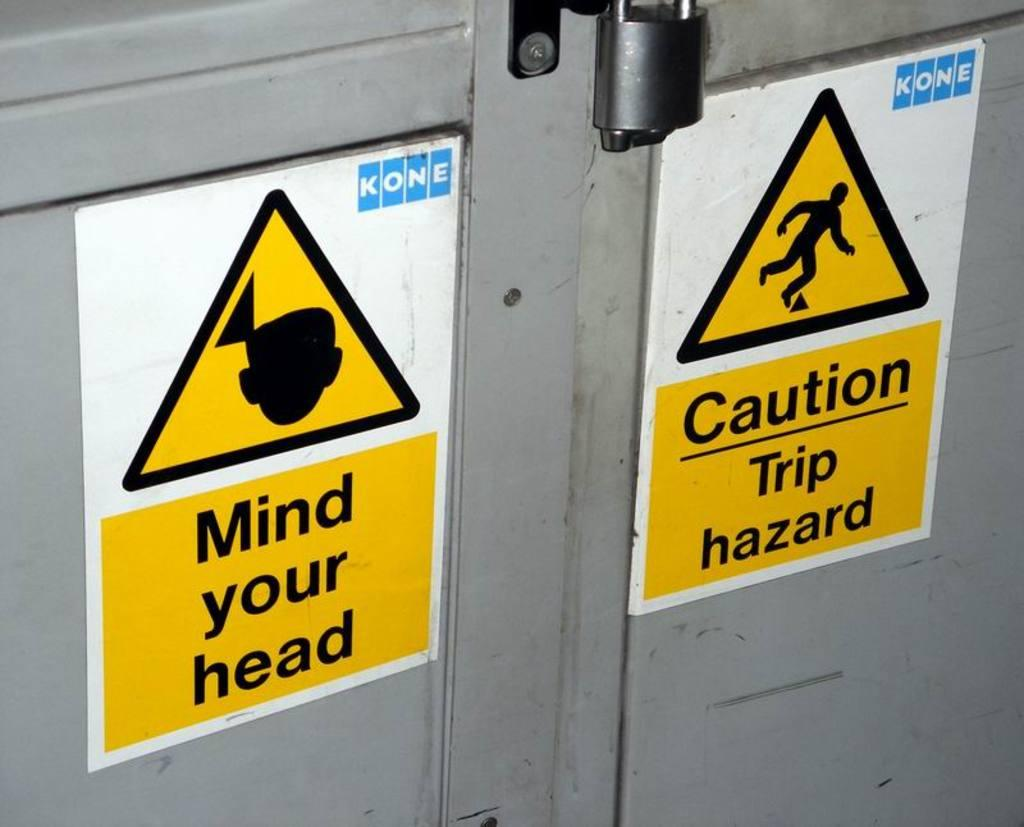<image>
Offer a succinct explanation of the picture presented. Two signs on a door warning people of potential hazards 